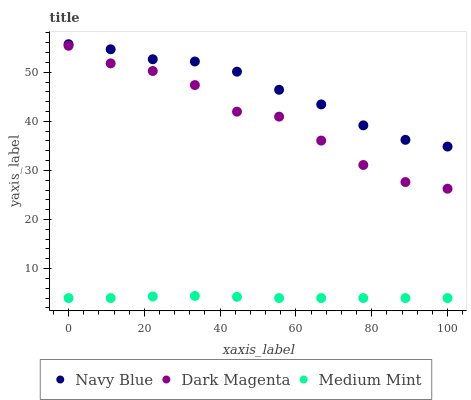Does Medium Mint have the minimum area under the curve?
Answer yes or no. Yes. Does Navy Blue have the maximum area under the curve?
Answer yes or no. Yes. Does Dark Magenta have the minimum area under the curve?
Answer yes or no. No. Does Dark Magenta have the maximum area under the curve?
Answer yes or no. No. Is Medium Mint the smoothest?
Answer yes or no. Yes. Is Dark Magenta the roughest?
Answer yes or no. Yes. Is Navy Blue the smoothest?
Answer yes or no. No. Is Navy Blue the roughest?
Answer yes or no. No. Does Medium Mint have the lowest value?
Answer yes or no. Yes. Does Dark Magenta have the lowest value?
Answer yes or no. No. Does Navy Blue have the highest value?
Answer yes or no. Yes. Does Dark Magenta have the highest value?
Answer yes or no. No. Is Medium Mint less than Navy Blue?
Answer yes or no. Yes. Is Dark Magenta greater than Medium Mint?
Answer yes or no. Yes. Does Medium Mint intersect Navy Blue?
Answer yes or no. No. 